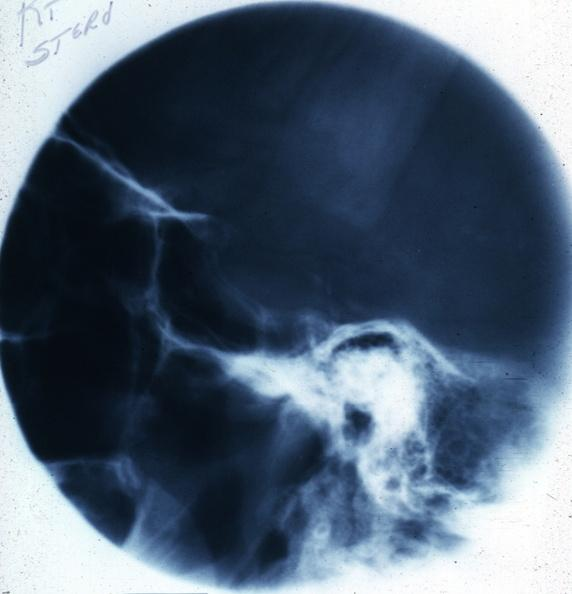where does this x-ray been taken?
Answer the question using a single word or phrase. Endocrine system 